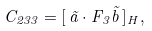Convert formula to latex. <formula><loc_0><loc_0><loc_500><loc_500>C _ { 2 3 3 } = [ \, \vec { a } \cdot F _ { 3 } \vec { b } \, ] _ { H } ,</formula> 